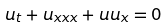<formula> <loc_0><loc_0><loc_500><loc_500>u _ { t } + u _ { x x x } + u u _ { x } = 0</formula> 